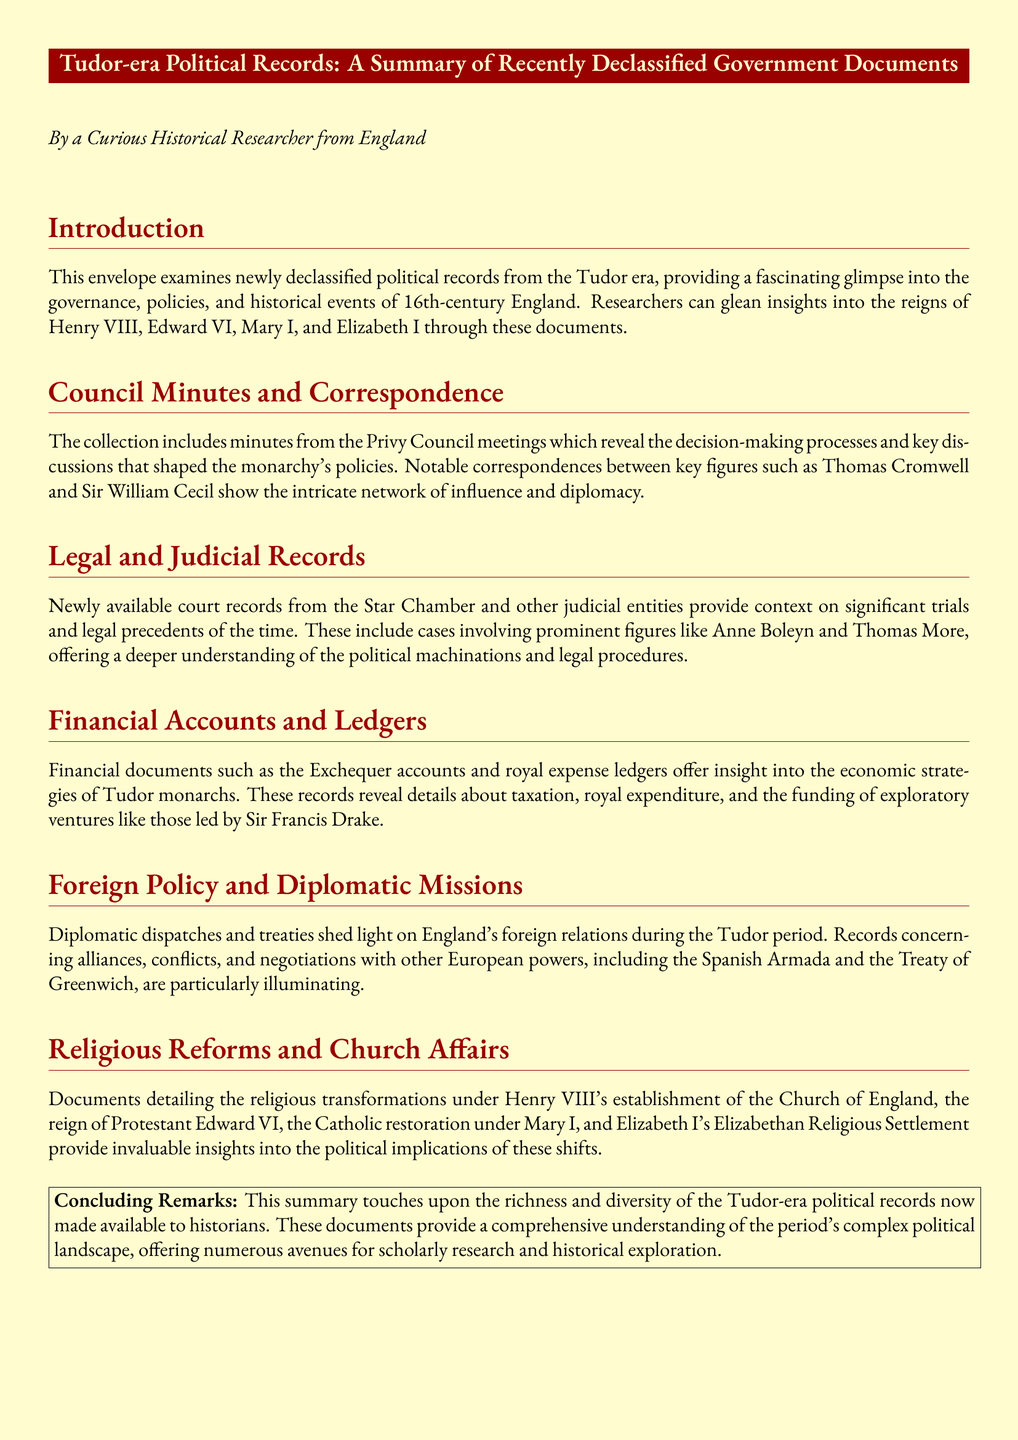What is the title of the document? The title of the document is stated at the top of the summary, providing an overview of its content.
Answer: Tudor-era Political Records: A Summary of Recently Declassified Government Documents Which monarch's religious reformation is discussed? The document mentions religious transformations specifically under Henry VIII, indicating a focus on his reign.
Answer: Henry VIII What type of records are included in the collection? The document outlines various types of documents, highlighting their significance in understanding Tudor governance.
Answer: Council Minutes and Correspondence Who was a key figure in the correspondence mentioned? The summary highlights important correspondences, specifically naming one influential individual notable in the Tudor court.
Answer: Thomas Cromwell What significant event is associated with the Treaty of Greenwich? The document outlines the context of foreign relations, emphasizing a key historical diplomatic event during the period.
Answer: Spanish Armada Which trial is indicated within the judicial records? The summary refers to prominent figures involved in notable trials, which showcases the political climate of the Tudor era.
Answer: Anne Boleyn What economic records are mentioned in the document? The financial aspects outlined in the summary touch upon specific documents that detail the economic situation of Tudor monarchs.
Answer: Exchequer accounts What was the role of Elizabeth I mentioned in the document? The document references Elizabeth I within the context of the religious settlement, highlighting her influence on religious matters.
Answer: Elizabethan Religious Settlement 